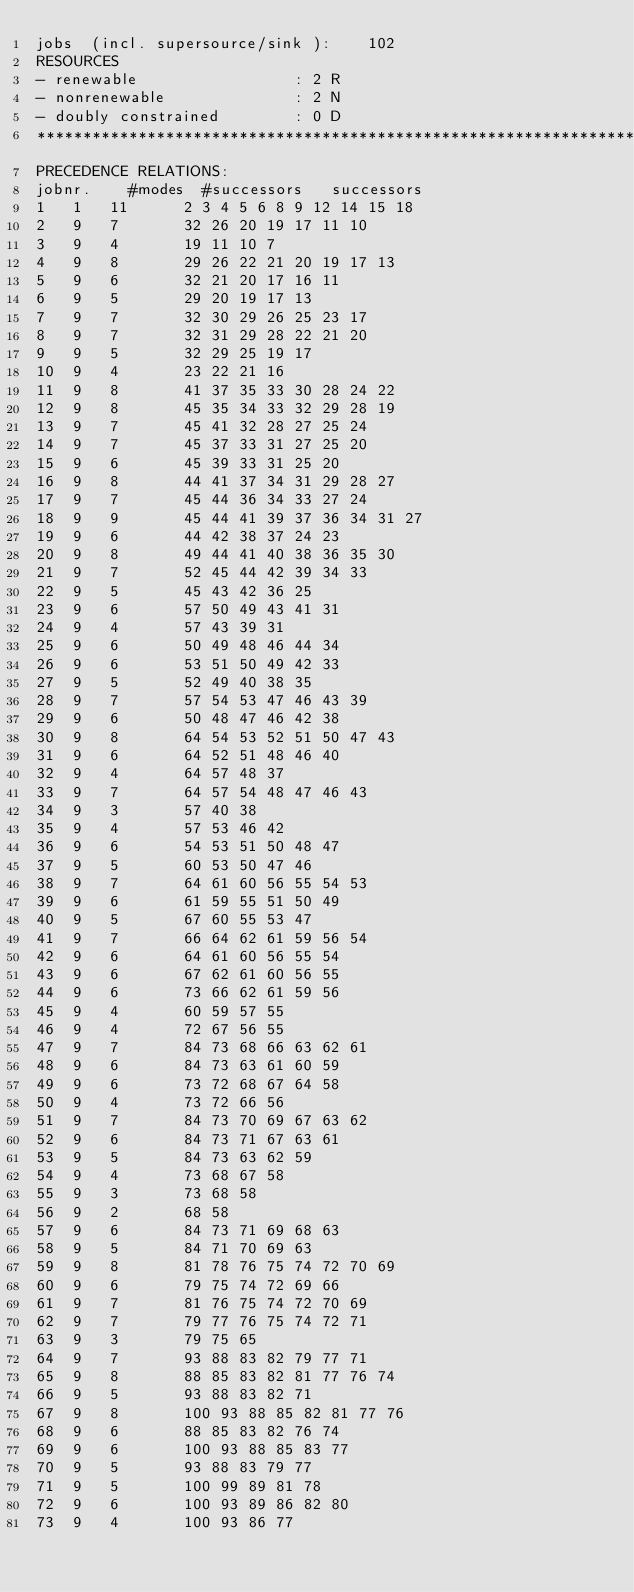Convert code to text. <code><loc_0><loc_0><loc_500><loc_500><_ObjectiveC_>jobs  (incl. supersource/sink ):	102
RESOURCES
- renewable                 : 2 R
- nonrenewable              : 2 N
- doubly constrained        : 0 D
************************************************************************
PRECEDENCE RELATIONS:
jobnr.    #modes  #successors   successors
1	1	11		2 3 4 5 6 8 9 12 14 15 18 
2	9	7		32 26 20 19 17 11 10 
3	9	4		19 11 10 7 
4	9	8		29 26 22 21 20 19 17 13 
5	9	6		32 21 20 17 16 11 
6	9	5		29 20 19 17 13 
7	9	7		32 30 29 26 25 23 17 
8	9	7		32 31 29 28 22 21 20 
9	9	5		32 29 25 19 17 
10	9	4		23 22 21 16 
11	9	8		41 37 35 33 30 28 24 22 
12	9	8		45 35 34 33 32 29 28 19 
13	9	7		45 41 32 28 27 25 24 
14	9	7		45 37 33 31 27 25 20 
15	9	6		45 39 33 31 25 20 
16	9	8		44 41 37 34 31 29 28 27 
17	9	7		45 44 36 34 33 27 24 
18	9	9		45 44 41 39 37 36 34 31 27 
19	9	6		44 42 38 37 24 23 
20	9	8		49 44 41 40 38 36 35 30 
21	9	7		52 45 44 42 39 34 33 
22	9	5		45 43 42 36 25 
23	9	6		57 50 49 43 41 31 
24	9	4		57 43 39 31 
25	9	6		50 49 48 46 44 34 
26	9	6		53 51 50 49 42 33 
27	9	5		52 49 40 38 35 
28	9	7		57 54 53 47 46 43 39 
29	9	6		50 48 47 46 42 38 
30	9	8		64 54 53 52 51 50 47 43 
31	9	6		64 52 51 48 46 40 
32	9	4		64 57 48 37 
33	9	7		64 57 54 48 47 46 43 
34	9	3		57 40 38 
35	9	4		57 53 46 42 
36	9	6		54 53 51 50 48 47 
37	9	5		60 53 50 47 46 
38	9	7		64 61 60 56 55 54 53 
39	9	6		61 59 55 51 50 49 
40	9	5		67 60 55 53 47 
41	9	7		66 64 62 61 59 56 54 
42	9	6		64 61 60 56 55 54 
43	9	6		67 62 61 60 56 55 
44	9	6		73 66 62 61 59 56 
45	9	4		60 59 57 55 
46	9	4		72 67 56 55 
47	9	7		84 73 68 66 63 62 61 
48	9	6		84 73 63 61 60 59 
49	9	6		73 72 68 67 64 58 
50	9	4		73 72 66 56 
51	9	7		84 73 70 69 67 63 62 
52	9	6		84 73 71 67 63 61 
53	9	5		84 73 63 62 59 
54	9	4		73 68 67 58 
55	9	3		73 68 58 
56	9	2		68 58 
57	9	6		84 73 71 69 68 63 
58	9	5		84 71 70 69 63 
59	9	8		81 78 76 75 74 72 70 69 
60	9	6		79 75 74 72 69 66 
61	9	7		81 76 75 74 72 70 69 
62	9	7		79 77 76 75 74 72 71 
63	9	3		79 75 65 
64	9	7		93 88 83 82 79 77 71 
65	9	8		88 85 83 82 81 77 76 74 
66	9	5		93 88 83 82 71 
67	9	8		100 93 88 85 82 81 77 76 
68	9	6		88 85 83 82 76 74 
69	9	6		100 93 88 85 83 77 
70	9	5		93 88 83 79 77 
71	9	5		100 99 89 81 78 
72	9	6		100 93 89 86 82 80 
73	9	4		100 93 86 77 </code> 